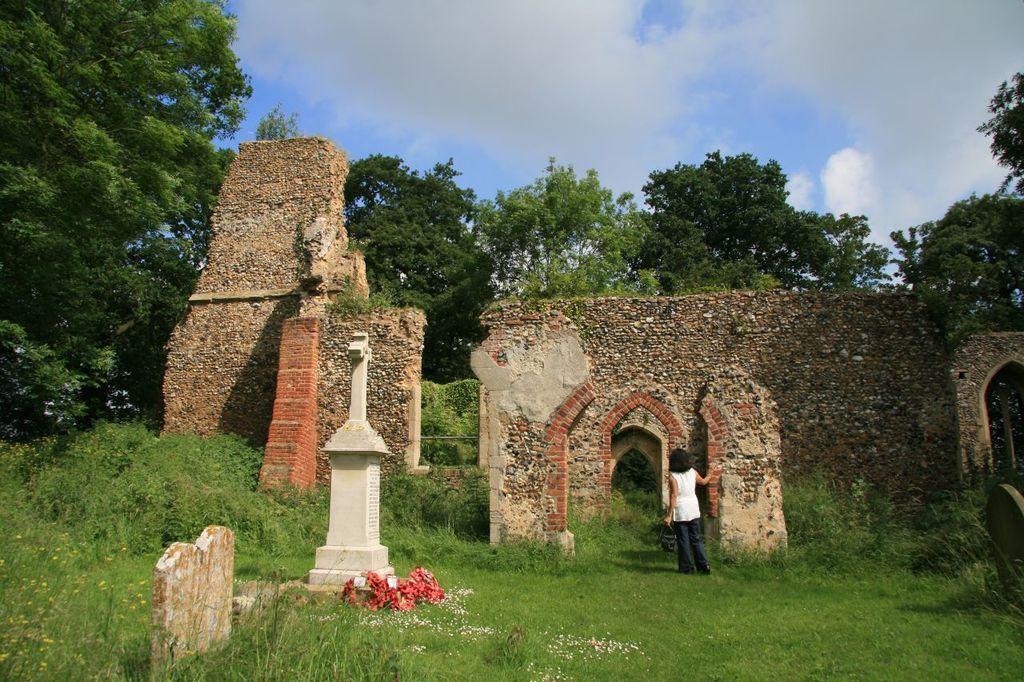How would you summarize this image in a sentence or two? In this image I can see collapsed building, in front of the building I can see a person standing on grass and I can see the sky and tree at the top. 